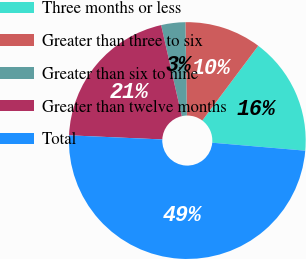<chart> <loc_0><loc_0><loc_500><loc_500><pie_chart><fcel>Three months or less<fcel>Greater than three to six<fcel>Greater than six to nine<fcel>Greater than twelve months<fcel>Total<nl><fcel>16.13%<fcel>10.49%<fcel>3.29%<fcel>20.74%<fcel>49.34%<nl></chart> 